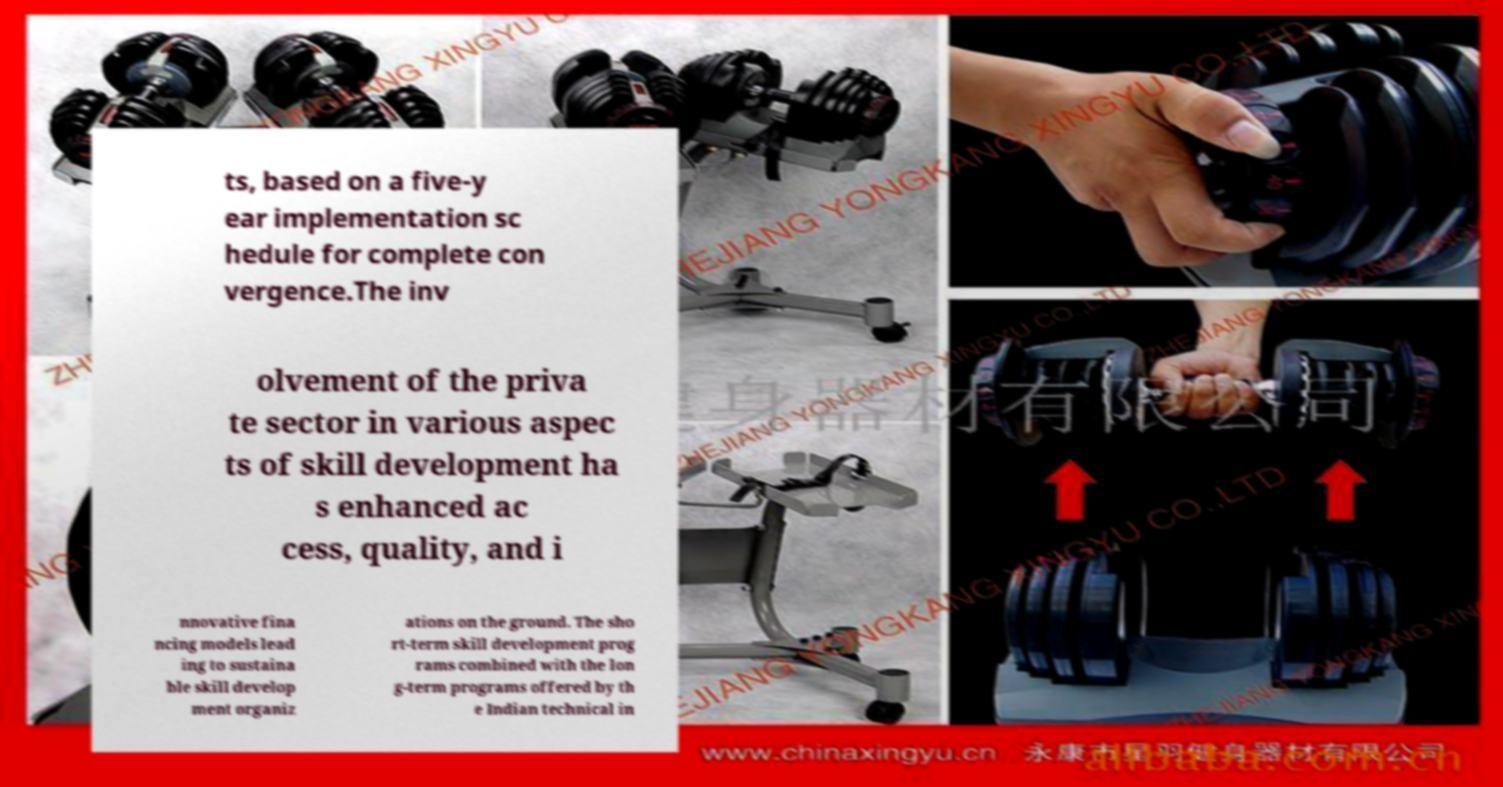Please read and relay the text visible in this image. What does it say? ts, based on a five-y ear implementation sc hedule for complete con vergence.The inv olvement of the priva te sector in various aspec ts of skill development ha s enhanced ac cess, quality, and i nnovative fina ncing models lead ing to sustaina ble skill develop ment organiz ations on the ground. The sho rt-term skill development prog rams combined with the lon g-term programs offered by th e Indian technical in 